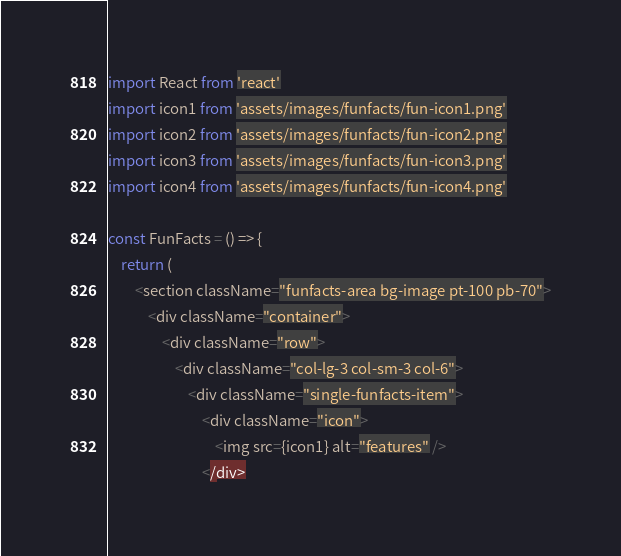<code> <loc_0><loc_0><loc_500><loc_500><_JavaScript_>import React from 'react'
import icon1 from 'assets/images/funfacts/fun-icon1.png'
import icon2 from 'assets/images/funfacts/fun-icon2.png'
import icon3 from 'assets/images/funfacts/fun-icon3.png'
import icon4 from 'assets/images/funfacts/fun-icon4.png'

const FunFacts = () => {
    return (
        <section className="funfacts-area bg-image pt-100 pb-70">
            <div className="container">
                <div className="row">
                    <div className="col-lg-3 col-sm-3 col-6">
                        <div className="single-funfacts-item">
                            <div className="icon">
                                <img src={icon1} alt="features" />
                            </div></code> 